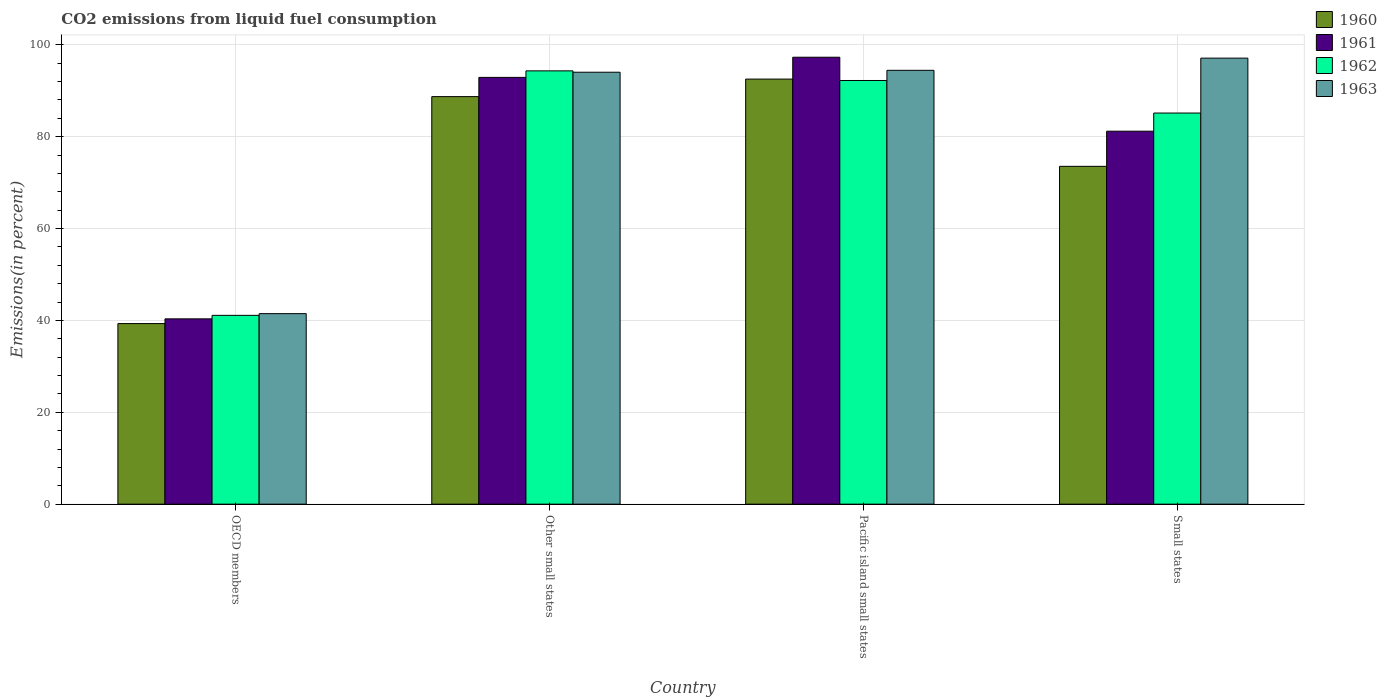How many different coloured bars are there?
Give a very brief answer. 4. Are the number of bars on each tick of the X-axis equal?
Ensure brevity in your answer.  Yes. How many bars are there on the 1st tick from the left?
Give a very brief answer. 4. How many bars are there on the 2nd tick from the right?
Offer a terse response. 4. What is the label of the 2nd group of bars from the left?
Make the answer very short. Other small states. What is the total CO2 emitted in 1963 in OECD members?
Keep it short and to the point. 41.48. Across all countries, what is the maximum total CO2 emitted in 1962?
Provide a succinct answer. 94.33. Across all countries, what is the minimum total CO2 emitted in 1961?
Make the answer very short. 40.34. In which country was the total CO2 emitted in 1963 maximum?
Give a very brief answer. Small states. What is the total total CO2 emitted in 1962 in the graph?
Offer a very short reply. 312.81. What is the difference between the total CO2 emitted in 1962 in Other small states and that in Small states?
Keep it short and to the point. 9.18. What is the difference between the total CO2 emitted in 1961 in Pacific island small states and the total CO2 emitted in 1960 in Other small states?
Provide a short and direct response. 8.58. What is the average total CO2 emitted in 1961 per country?
Ensure brevity in your answer.  77.93. What is the difference between the total CO2 emitted of/in 1963 and total CO2 emitted of/in 1961 in Other small states?
Keep it short and to the point. 1.12. What is the ratio of the total CO2 emitted in 1961 in OECD members to that in Pacific island small states?
Give a very brief answer. 0.41. Is the total CO2 emitted in 1963 in Other small states less than that in Pacific island small states?
Keep it short and to the point. Yes. Is the difference between the total CO2 emitted in 1963 in OECD members and Pacific island small states greater than the difference between the total CO2 emitted in 1961 in OECD members and Pacific island small states?
Ensure brevity in your answer.  Yes. What is the difference between the highest and the second highest total CO2 emitted in 1960?
Your answer should be very brief. 15.18. What is the difference between the highest and the lowest total CO2 emitted in 1961?
Make the answer very short. 56.96. Is the sum of the total CO2 emitted in 1963 in Other small states and Pacific island small states greater than the maximum total CO2 emitted in 1960 across all countries?
Ensure brevity in your answer.  Yes. What does the 2nd bar from the right in Pacific island small states represents?
Offer a terse response. 1962. Is it the case that in every country, the sum of the total CO2 emitted in 1962 and total CO2 emitted in 1961 is greater than the total CO2 emitted in 1963?
Your answer should be very brief. Yes. How many bars are there?
Your answer should be very brief. 16. Does the graph contain any zero values?
Provide a short and direct response. No. What is the title of the graph?
Your answer should be compact. CO2 emissions from liquid fuel consumption. Does "1973" appear as one of the legend labels in the graph?
Your answer should be compact. No. What is the label or title of the Y-axis?
Ensure brevity in your answer.  Emissions(in percent). What is the Emissions(in percent) of 1960 in OECD members?
Ensure brevity in your answer.  39.31. What is the Emissions(in percent) of 1961 in OECD members?
Offer a very short reply. 40.34. What is the Emissions(in percent) in 1962 in OECD members?
Your answer should be compact. 41.1. What is the Emissions(in percent) of 1963 in OECD members?
Your answer should be compact. 41.48. What is the Emissions(in percent) of 1960 in Other small states?
Your response must be concise. 88.72. What is the Emissions(in percent) in 1961 in Other small states?
Offer a very short reply. 92.91. What is the Emissions(in percent) of 1962 in Other small states?
Your response must be concise. 94.33. What is the Emissions(in percent) in 1963 in Other small states?
Provide a short and direct response. 94.03. What is the Emissions(in percent) of 1960 in Pacific island small states?
Keep it short and to the point. 92.54. What is the Emissions(in percent) of 1961 in Pacific island small states?
Provide a succinct answer. 97.3. What is the Emissions(in percent) in 1962 in Pacific island small states?
Your answer should be very brief. 92.23. What is the Emissions(in percent) of 1963 in Pacific island small states?
Provide a succinct answer. 94.44. What is the Emissions(in percent) in 1960 in Small states?
Provide a succinct answer. 73.54. What is the Emissions(in percent) in 1961 in Small states?
Your response must be concise. 81.19. What is the Emissions(in percent) in 1962 in Small states?
Make the answer very short. 85.15. What is the Emissions(in percent) in 1963 in Small states?
Keep it short and to the point. 97.1. Across all countries, what is the maximum Emissions(in percent) of 1960?
Provide a succinct answer. 92.54. Across all countries, what is the maximum Emissions(in percent) of 1961?
Provide a short and direct response. 97.3. Across all countries, what is the maximum Emissions(in percent) in 1962?
Ensure brevity in your answer.  94.33. Across all countries, what is the maximum Emissions(in percent) of 1963?
Make the answer very short. 97.1. Across all countries, what is the minimum Emissions(in percent) in 1960?
Your answer should be very brief. 39.31. Across all countries, what is the minimum Emissions(in percent) of 1961?
Your answer should be very brief. 40.34. Across all countries, what is the minimum Emissions(in percent) of 1962?
Provide a short and direct response. 41.1. Across all countries, what is the minimum Emissions(in percent) in 1963?
Offer a terse response. 41.48. What is the total Emissions(in percent) of 1960 in the graph?
Your response must be concise. 294.12. What is the total Emissions(in percent) in 1961 in the graph?
Give a very brief answer. 311.74. What is the total Emissions(in percent) of 1962 in the graph?
Offer a very short reply. 312.81. What is the total Emissions(in percent) in 1963 in the graph?
Keep it short and to the point. 327.05. What is the difference between the Emissions(in percent) of 1960 in OECD members and that in Other small states?
Ensure brevity in your answer.  -49.41. What is the difference between the Emissions(in percent) of 1961 in OECD members and that in Other small states?
Your answer should be very brief. -52.57. What is the difference between the Emissions(in percent) in 1962 in OECD members and that in Other small states?
Provide a short and direct response. -53.22. What is the difference between the Emissions(in percent) of 1963 in OECD members and that in Other small states?
Your answer should be very brief. -52.55. What is the difference between the Emissions(in percent) in 1960 in OECD members and that in Pacific island small states?
Keep it short and to the point. -53.23. What is the difference between the Emissions(in percent) in 1961 in OECD members and that in Pacific island small states?
Offer a very short reply. -56.96. What is the difference between the Emissions(in percent) of 1962 in OECD members and that in Pacific island small states?
Make the answer very short. -51.13. What is the difference between the Emissions(in percent) in 1963 in OECD members and that in Pacific island small states?
Your answer should be very brief. -52.97. What is the difference between the Emissions(in percent) in 1960 in OECD members and that in Small states?
Ensure brevity in your answer.  -34.23. What is the difference between the Emissions(in percent) of 1961 in OECD members and that in Small states?
Make the answer very short. -40.85. What is the difference between the Emissions(in percent) in 1962 in OECD members and that in Small states?
Keep it short and to the point. -44.04. What is the difference between the Emissions(in percent) of 1963 in OECD members and that in Small states?
Keep it short and to the point. -55.62. What is the difference between the Emissions(in percent) in 1960 in Other small states and that in Pacific island small states?
Your response must be concise. -3.82. What is the difference between the Emissions(in percent) of 1961 in Other small states and that in Pacific island small states?
Give a very brief answer. -4.39. What is the difference between the Emissions(in percent) of 1962 in Other small states and that in Pacific island small states?
Make the answer very short. 2.09. What is the difference between the Emissions(in percent) in 1963 in Other small states and that in Pacific island small states?
Keep it short and to the point. -0.41. What is the difference between the Emissions(in percent) in 1960 in Other small states and that in Small states?
Offer a terse response. 15.18. What is the difference between the Emissions(in percent) in 1961 in Other small states and that in Small states?
Give a very brief answer. 11.72. What is the difference between the Emissions(in percent) of 1962 in Other small states and that in Small states?
Keep it short and to the point. 9.18. What is the difference between the Emissions(in percent) of 1963 in Other small states and that in Small states?
Make the answer very short. -3.07. What is the difference between the Emissions(in percent) in 1960 in Pacific island small states and that in Small states?
Your answer should be compact. 18.99. What is the difference between the Emissions(in percent) of 1961 in Pacific island small states and that in Small states?
Give a very brief answer. 16.1. What is the difference between the Emissions(in percent) of 1962 in Pacific island small states and that in Small states?
Ensure brevity in your answer.  7.09. What is the difference between the Emissions(in percent) in 1963 in Pacific island small states and that in Small states?
Offer a very short reply. -2.66. What is the difference between the Emissions(in percent) of 1960 in OECD members and the Emissions(in percent) of 1961 in Other small states?
Provide a succinct answer. -53.6. What is the difference between the Emissions(in percent) in 1960 in OECD members and the Emissions(in percent) in 1962 in Other small states?
Keep it short and to the point. -55.01. What is the difference between the Emissions(in percent) of 1960 in OECD members and the Emissions(in percent) of 1963 in Other small states?
Offer a very short reply. -54.72. What is the difference between the Emissions(in percent) in 1961 in OECD members and the Emissions(in percent) in 1962 in Other small states?
Ensure brevity in your answer.  -53.99. What is the difference between the Emissions(in percent) of 1961 in OECD members and the Emissions(in percent) of 1963 in Other small states?
Make the answer very short. -53.69. What is the difference between the Emissions(in percent) in 1962 in OECD members and the Emissions(in percent) in 1963 in Other small states?
Provide a short and direct response. -52.93. What is the difference between the Emissions(in percent) in 1960 in OECD members and the Emissions(in percent) in 1961 in Pacific island small states?
Your answer should be very brief. -57.99. What is the difference between the Emissions(in percent) in 1960 in OECD members and the Emissions(in percent) in 1962 in Pacific island small states?
Keep it short and to the point. -52.92. What is the difference between the Emissions(in percent) of 1960 in OECD members and the Emissions(in percent) of 1963 in Pacific island small states?
Your response must be concise. -55.13. What is the difference between the Emissions(in percent) in 1961 in OECD members and the Emissions(in percent) in 1962 in Pacific island small states?
Give a very brief answer. -51.89. What is the difference between the Emissions(in percent) of 1961 in OECD members and the Emissions(in percent) of 1963 in Pacific island small states?
Give a very brief answer. -54.1. What is the difference between the Emissions(in percent) of 1962 in OECD members and the Emissions(in percent) of 1963 in Pacific island small states?
Give a very brief answer. -53.34. What is the difference between the Emissions(in percent) of 1960 in OECD members and the Emissions(in percent) of 1961 in Small states?
Your answer should be very brief. -41.88. What is the difference between the Emissions(in percent) of 1960 in OECD members and the Emissions(in percent) of 1962 in Small states?
Your response must be concise. -45.84. What is the difference between the Emissions(in percent) of 1960 in OECD members and the Emissions(in percent) of 1963 in Small states?
Provide a short and direct response. -57.79. What is the difference between the Emissions(in percent) in 1961 in OECD members and the Emissions(in percent) in 1962 in Small states?
Your answer should be very brief. -44.81. What is the difference between the Emissions(in percent) in 1961 in OECD members and the Emissions(in percent) in 1963 in Small states?
Offer a terse response. -56.76. What is the difference between the Emissions(in percent) of 1962 in OECD members and the Emissions(in percent) of 1963 in Small states?
Make the answer very short. -55.99. What is the difference between the Emissions(in percent) in 1960 in Other small states and the Emissions(in percent) in 1961 in Pacific island small states?
Your answer should be very brief. -8.58. What is the difference between the Emissions(in percent) of 1960 in Other small states and the Emissions(in percent) of 1962 in Pacific island small states?
Offer a terse response. -3.51. What is the difference between the Emissions(in percent) in 1960 in Other small states and the Emissions(in percent) in 1963 in Pacific island small states?
Provide a short and direct response. -5.72. What is the difference between the Emissions(in percent) of 1961 in Other small states and the Emissions(in percent) of 1962 in Pacific island small states?
Ensure brevity in your answer.  0.67. What is the difference between the Emissions(in percent) in 1961 in Other small states and the Emissions(in percent) in 1963 in Pacific island small states?
Your response must be concise. -1.54. What is the difference between the Emissions(in percent) in 1962 in Other small states and the Emissions(in percent) in 1963 in Pacific island small states?
Offer a very short reply. -0.12. What is the difference between the Emissions(in percent) in 1960 in Other small states and the Emissions(in percent) in 1961 in Small states?
Provide a succinct answer. 7.53. What is the difference between the Emissions(in percent) in 1960 in Other small states and the Emissions(in percent) in 1962 in Small states?
Give a very brief answer. 3.57. What is the difference between the Emissions(in percent) of 1960 in Other small states and the Emissions(in percent) of 1963 in Small states?
Provide a short and direct response. -8.38. What is the difference between the Emissions(in percent) in 1961 in Other small states and the Emissions(in percent) in 1962 in Small states?
Keep it short and to the point. 7.76. What is the difference between the Emissions(in percent) of 1961 in Other small states and the Emissions(in percent) of 1963 in Small states?
Give a very brief answer. -4.19. What is the difference between the Emissions(in percent) of 1962 in Other small states and the Emissions(in percent) of 1963 in Small states?
Give a very brief answer. -2.77. What is the difference between the Emissions(in percent) of 1960 in Pacific island small states and the Emissions(in percent) of 1961 in Small states?
Your answer should be compact. 11.34. What is the difference between the Emissions(in percent) in 1960 in Pacific island small states and the Emissions(in percent) in 1962 in Small states?
Your answer should be very brief. 7.39. What is the difference between the Emissions(in percent) in 1960 in Pacific island small states and the Emissions(in percent) in 1963 in Small states?
Your response must be concise. -4.56. What is the difference between the Emissions(in percent) in 1961 in Pacific island small states and the Emissions(in percent) in 1962 in Small states?
Provide a short and direct response. 12.15. What is the difference between the Emissions(in percent) of 1961 in Pacific island small states and the Emissions(in percent) of 1963 in Small states?
Your answer should be very brief. 0.2. What is the difference between the Emissions(in percent) in 1962 in Pacific island small states and the Emissions(in percent) in 1963 in Small states?
Your response must be concise. -4.87. What is the average Emissions(in percent) in 1960 per country?
Your response must be concise. 73.53. What is the average Emissions(in percent) in 1961 per country?
Ensure brevity in your answer.  77.93. What is the average Emissions(in percent) in 1962 per country?
Your answer should be very brief. 78.2. What is the average Emissions(in percent) of 1963 per country?
Your answer should be very brief. 81.76. What is the difference between the Emissions(in percent) of 1960 and Emissions(in percent) of 1961 in OECD members?
Keep it short and to the point. -1.03. What is the difference between the Emissions(in percent) of 1960 and Emissions(in percent) of 1962 in OECD members?
Your response must be concise. -1.79. What is the difference between the Emissions(in percent) in 1960 and Emissions(in percent) in 1963 in OECD members?
Your answer should be very brief. -2.16. What is the difference between the Emissions(in percent) in 1961 and Emissions(in percent) in 1962 in OECD members?
Give a very brief answer. -0.76. What is the difference between the Emissions(in percent) of 1961 and Emissions(in percent) of 1963 in OECD members?
Your response must be concise. -1.14. What is the difference between the Emissions(in percent) in 1962 and Emissions(in percent) in 1963 in OECD members?
Your answer should be compact. -0.37. What is the difference between the Emissions(in percent) in 1960 and Emissions(in percent) in 1961 in Other small states?
Give a very brief answer. -4.19. What is the difference between the Emissions(in percent) of 1960 and Emissions(in percent) of 1962 in Other small states?
Offer a terse response. -5.6. What is the difference between the Emissions(in percent) in 1960 and Emissions(in percent) in 1963 in Other small states?
Your answer should be very brief. -5.31. What is the difference between the Emissions(in percent) in 1961 and Emissions(in percent) in 1962 in Other small states?
Your answer should be very brief. -1.42. What is the difference between the Emissions(in percent) in 1961 and Emissions(in percent) in 1963 in Other small states?
Offer a very short reply. -1.12. What is the difference between the Emissions(in percent) in 1962 and Emissions(in percent) in 1963 in Other small states?
Keep it short and to the point. 0.3. What is the difference between the Emissions(in percent) in 1960 and Emissions(in percent) in 1961 in Pacific island small states?
Keep it short and to the point. -4.76. What is the difference between the Emissions(in percent) of 1960 and Emissions(in percent) of 1962 in Pacific island small states?
Keep it short and to the point. 0.3. What is the difference between the Emissions(in percent) of 1960 and Emissions(in percent) of 1963 in Pacific island small states?
Give a very brief answer. -1.91. What is the difference between the Emissions(in percent) in 1961 and Emissions(in percent) in 1962 in Pacific island small states?
Provide a short and direct response. 5.06. What is the difference between the Emissions(in percent) of 1961 and Emissions(in percent) of 1963 in Pacific island small states?
Provide a succinct answer. 2.85. What is the difference between the Emissions(in percent) of 1962 and Emissions(in percent) of 1963 in Pacific island small states?
Offer a terse response. -2.21. What is the difference between the Emissions(in percent) in 1960 and Emissions(in percent) in 1961 in Small states?
Your answer should be very brief. -7.65. What is the difference between the Emissions(in percent) in 1960 and Emissions(in percent) in 1962 in Small states?
Ensure brevity in your answer.  -11.6. What is the difference between the Emissions(in percent) in 1960 and Emissions(in percent) in 1963 in Small states?
Your answer should be very brief. -23.56. What is the difference between the Emissions(in percent) of 1961 and Emissions(in percent) of 1962 in Small states?
Keep it short and to the point. -3.96. What is the difference between the Emissions(in percent) of 1961 and Emissions(in percent) of 1963 in Small states?
Your answer should be compact. -15.91. What is the difference between the Emissions(in percent) in 1962 and Emissions(in percent) in 1963 in Small states?
Ensure brevity in your answer.  -11.95. What is the ratio of the Emissions(in percent) of 1960 in OECD members to that in Other small states?
Give a very brief answer. 0.44. What is the ratio of the Emissions(in percent) in 1961 in OECD members to that in Other small states?
Ensure brevity in your answer.  0.43. What is the ratio of the Emissions(in percent) of 1962 in OECD members to that in Other small states?
Give a very brief answer. 0.44. What is the ratio of the Emissions(in percent) of 1963 in OECD members to that in Other small states?
Your answer should be compact. 0.44. What is the ratio of the Emissions(in percent) of 1960 in OECD members to that in Pacific island small states?
Provide a short and direct response. 0.42. What is the ratio of the Emissions(in percent) of 1961 in OECD members to that in Pacific island small states?
Your answer should be very brief. 0.41. What is the ratio of the Emissions(in percent) of 1962 in OECD members to that in Pacific island small states?
Provide a short and direct response. 0.45. What is the ratio of the Emissions(in percent) in 1963 in OECD members to that in Pacific island small states?
Ensure brevity in your answer.  0.44. What is the ratio of the Emissions(in percent) of 1960 in OECD members to that in Small states?
Provide a succinct answer. 0.53. What is the ratio of the Emissions(in percent) in 1961 in OECD members to that in Small states?
Your answer should be compact. 0.5. What is the ratio of the Emissions(in percent) in 1962 in OECD members to that in Small states?
Ensure brevity in your answer.  0.48. What is the ratio of the Emissions(in percent) in 1963 in OECD members to that in Small states?
Provide a short and direct response. 0.43. What is the ratio of the Emissions(in percent) of 1960 in Other small states to that in Pacific island small states?
Make the answer very short. 0.96. What is the ratio of the Emissions(in percent) in 1961 in Other small states to that in Pacific island small states?
Keep it short and to the point. 0.95. What is the ratio of the Emissions(in percent) in 1962 in Other small states to that in Pacific island small states?
Offer a terse response. 1.02. What is the ratio of the Emissions(in percent) in 1963 in Other small states to that in Pacific island small states?
Offer a very short reply. 1. What is the ratio of the Emissions(in percent) of 1960 in Other small states to that in Small states?
Keep it short and to the point. 1.21. What is the ratio of the Emissions(in percent) of 1961 in Other small states to that in Small states?
Keep it short and to the point. 1.14. What is the ratio of the Emissions(in percent) in 1962 in Other small states to that in Small states?
Make the answer very short. 1.11. What is the ratio of the Emissions(in percent) in 1963 in Other small states to that in Small states?
Keep it short and to the point. 0.97. What is the ratio of the Emissions(in percent) in 1960 in Pacific island small states to that in Small states?
Offer a very short reply. 1.26. What is the ratio of the Emissions(in percent) of 1961 in Pacific island small states to that in Small states?
Your answer should be very brief. 1.2. What is the ratio of the Emissions(in percent) of 1962 in Pacific island small states to that in Small states?
Your response must be concise. 1.08. What is the ratio of the Emissions(in percent) in 1963 in Pacific island small states to that in Small states?
Give a very brief answer. 0.97. What is the difference between the highest and the second highest Emissions(in percent) in 1960?
Offer a very short reply. 3.82. What is the difference between the highest and the second highest Emissions(in percent) in 1961?
Make the answer very short. 4.39. What is the difference between the highest and the second highest Emissions(in percent) in 1962?
Offer a terse response. 2.09. What is the difference between the highest and the second highest Emissions(in percent) of 1963?
Your answer should be compact. 2.66. What is the difference between the highest and the lowest Emissions(in percent) in 1960?
Your answer should be very brief. 53.23. What is the difference between the highest and the lowest Emissions(in percent) in 1961?
Provide a short and direct response. 56.96. What is the difference between the highest and the lowest Emissions(in percent) of 1962?
Provide a succinct answer. 53.22. What is the difference between the highest and the lowest Emissions(in percent) of 1963?
Provide a succinct answer. 55.62. 